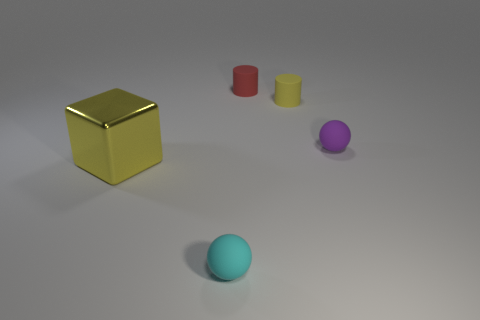Add 1 brown metallic balls. How many objects exist? 6 Subtract all cylinders. How many objects are left? 3 Subtract all tiny things. Subtract all big gray cubes. How many objects are left? 1 Add 2 rubber balls. How many rubber balls are left? 4 Add 2 cyan rubber objects. How many cyan rubber objects exist? 3 Subtract 0 cyan cylinders. How many objects are left? 5 